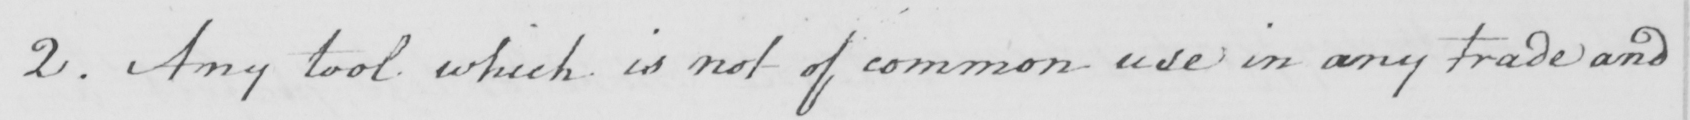Transcribe the text shown in this historical manuscript line. 2 . Any tool which is not of common use in any trade and 